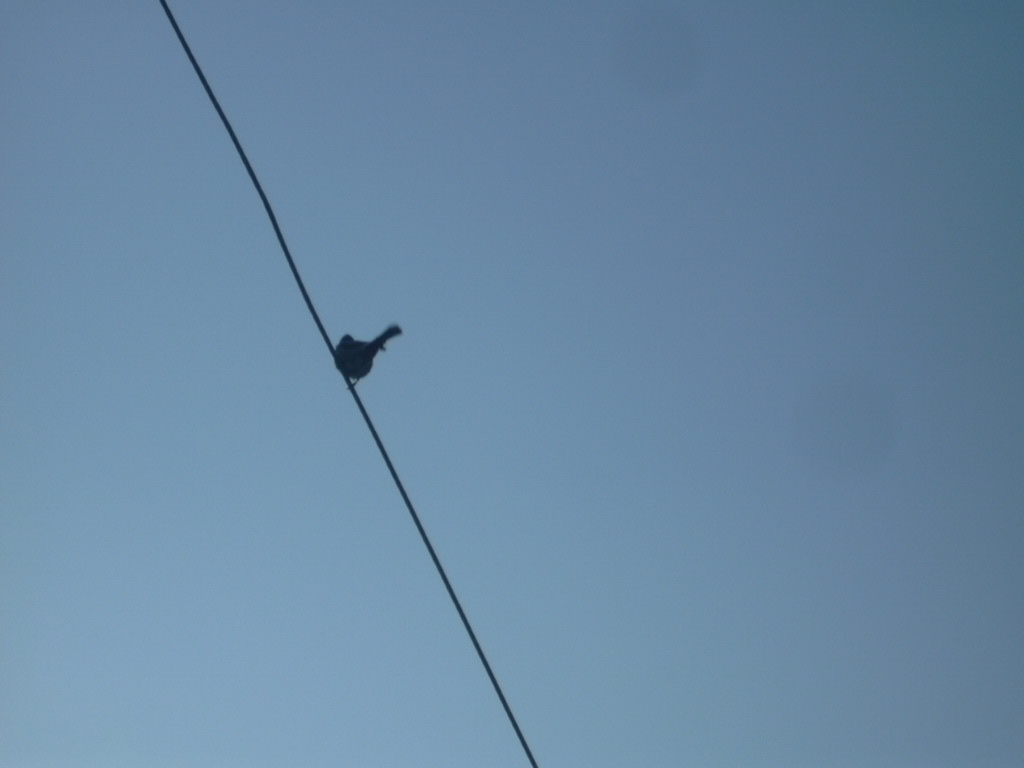What could be improved compositionally in this photograph? Improving the composition might include aligning the bird with one of the rule of thirds intersections, and adjusting the exposure to reveal more details in the bird's silhouette, while also considering the background to avoid overexposure of the sky. 